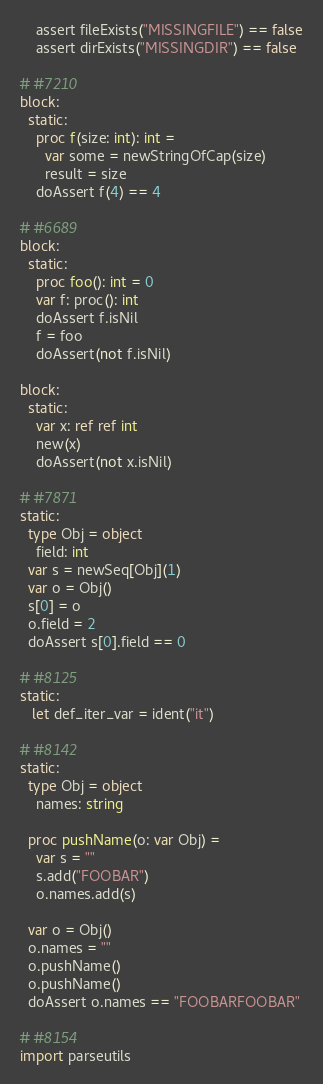<code> <loc_0><loc_0><loc_500><loc_500><_Nim_>
    assert fileExists("MISSINGFILE") == false
    assert dirExists("MISSINGDIR") == false

# #7210
block:
  static:
    proc f(size: int): int =
      var some = newStringOfCap(size)
      result = size
    doAssert f(4) == 4

# #6689
block:
  static:
    proc foo(): int = 0
    var f: proc(): int
    doAssert f.isNil
    f = foo
    doAssert(not f.isNil)

block:
  static:
    var x: ref ref int
    new(x)
    doAssert(not x.isNil)

# #7871
static:
  type Obj = object
    field: int
  var s = newSeq[Obj](1)
  var o = Obj()
  s[0] = o
  o.field = 2
  doAssert s[0].field == 0

# #8125
static:
   let def_iter_var = ident("it")

# #8142
static:
  type Obj = object
    names: string

  proc pushName(o: var Obj) =
    var s = ""
    s.add("FOOBAR")
    o.names.add(s)

  var o = Obj()
  o.names = ""
  o.pushName()
  o.pushName()
  doAssert o.names == "FOOBARFOOBAR"

# #8154
import parseutils
</code> 